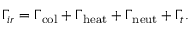<formula> <loc_0><loc_0><loc_500><loc_500>\Gamma _ { i r } = \Gamma _ { c o l } + \Gamma _ { h e a t } + \Gamma _ { n e u t } + \Gamma _ { t } .</formula> 